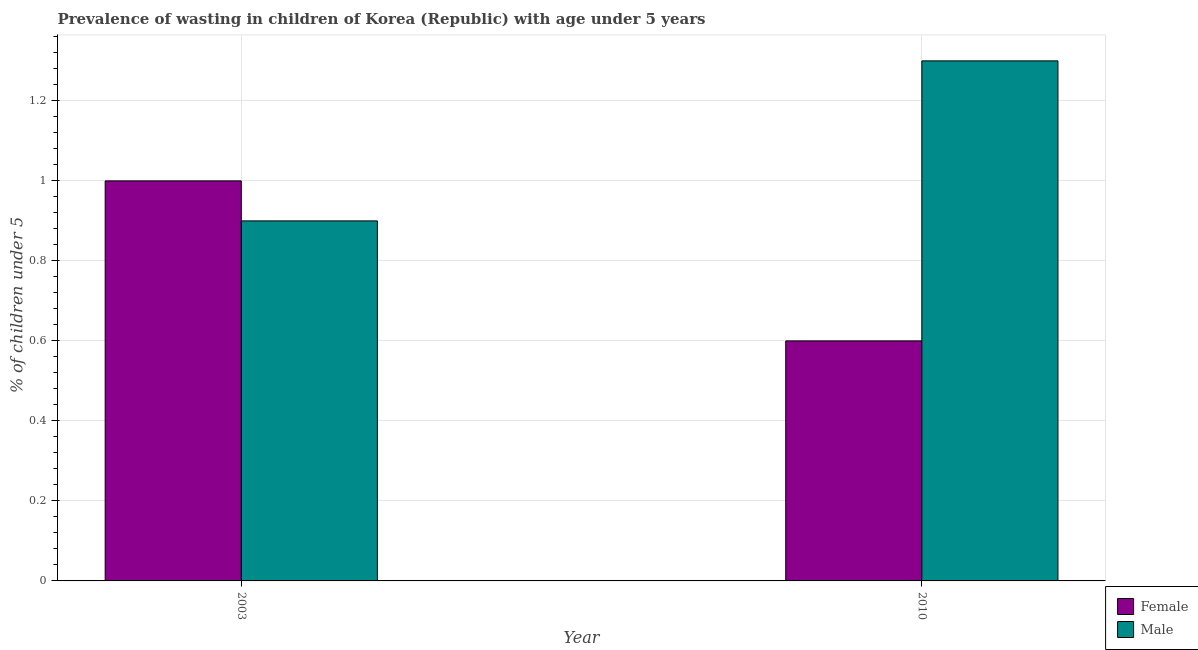How many groups of bars are there?
Keep it short and to the point. 2. Are the number of bars per tick equal to the number of legend labels?
Your answer should be compact. Yes. Are the number of bars on each tick of the X-axis equal?
Your response must be concise. Yes. How many bars are there on the 2nd tick from the right?
Offer a very short reply. 2. In how many cases, is the number of bars for a given year not equal to the number of legend labels?
Keep it short and to the point. 0. What is the percentage of undernourished male children in 2010?
Make the answer very short. 1.3. Across all years, what is the minimum percentage of undernourished female children?
Ensure brevity in your answer.  0.6. In which year was the percentage of undernourished male children maximum?
Make the answer very short. 2010. What is the total percentage of undernourished female children in the graph?
Give a very brief answer. 1.6. What is the difference between the percentage of undernourished male children in 2003 and that in 2010?
Offer a terse response. -0.4. What is the difference between the percentage of undernourished male children in 2010 and the percentage of undernourished female children in 2003?
Your answer should be very brief. 0.4. What is the average percentage of undernourished male children per year?
Offer a very short reply. 1.1. What is the ratio of the percentage of undernourished female children in 2003 to that in 2010?
Your response must be concise. 1.67. Is the percentage of undernourished female children in 2003 less than that in 2010?
Offer a very short reply. No. In how many years, is the percentage of undernourished female children greater than the average percentage of undernourished female children taken over all years?
Your answer should be compact. 1. Does the graph contain any zero values?
Your answer should be compact. No. Does the graph contain grids?
Offer a terse response. Yes. Where does the legend appear in the graph?
Offer a terse response. Bottom right. What is the title of the graph?
Offer a terse response. Prevalence of wasting in children of Korea (Republic) with age under 5 years. Does "Resident" appear as one of the legend labels in the graph?
Offer a very short reply. No. What is the label or title of the Y-axis?
Keep it short and to the point.  % of children under 5. What is the  % of children under 5 of Female in 2003?
Your answer should be very brief. 1. What is the  % of children under 5 in Male in 2003?
Keep it short and to the point. 0.9. What is the  % of children under 5 in Female in 2010?
Ensure brevity in your answer.  0.6. What is the  % of children under 5 of Male in 2010?
Your response must be concise. 1.3. Across all years, what is the maximum  % of children under 5 of Male?
Your answer should be very brief. 1.3. Across all years, what is the minimum  % of children under 5 in Female?
Offer a very short reply. 0.6. Across all years, what is the minimum  % of children under 5 of Male?
Your answer should be very brief. 0.9. What is the total  % of children under 5 in Female in the graph?
Ensure brevity in your answer.  1.6. What is the difference between the  % of children under 5 in Male in 2003 and that in 2010?
Offer a very short reply. -0.4. What is the average  % of children under 5 in Female per year?
Provide a succinct answer. 0.8. In the year 2010, what is the difference between the  % of children under 5 in Female and  % of children under 5 in Male?
Keep it short and to the point. -0.7. What is the ratio of the  % of children under 5 in Female in 2003 to that in 2010?
Offer a very short reply. 1.67. What is the ratio of the  % of children under 5 of Male in 2003 to that in 2010?
Offer a very short reply. 0.69. What is the difference between the highest and the lowest  % of children under 5 of Female?
Your response must be concise. 0.4. What is the difference between the highest and the lowest  % of children under 5 in Male?
Provide a short and direct response. 0.4. 